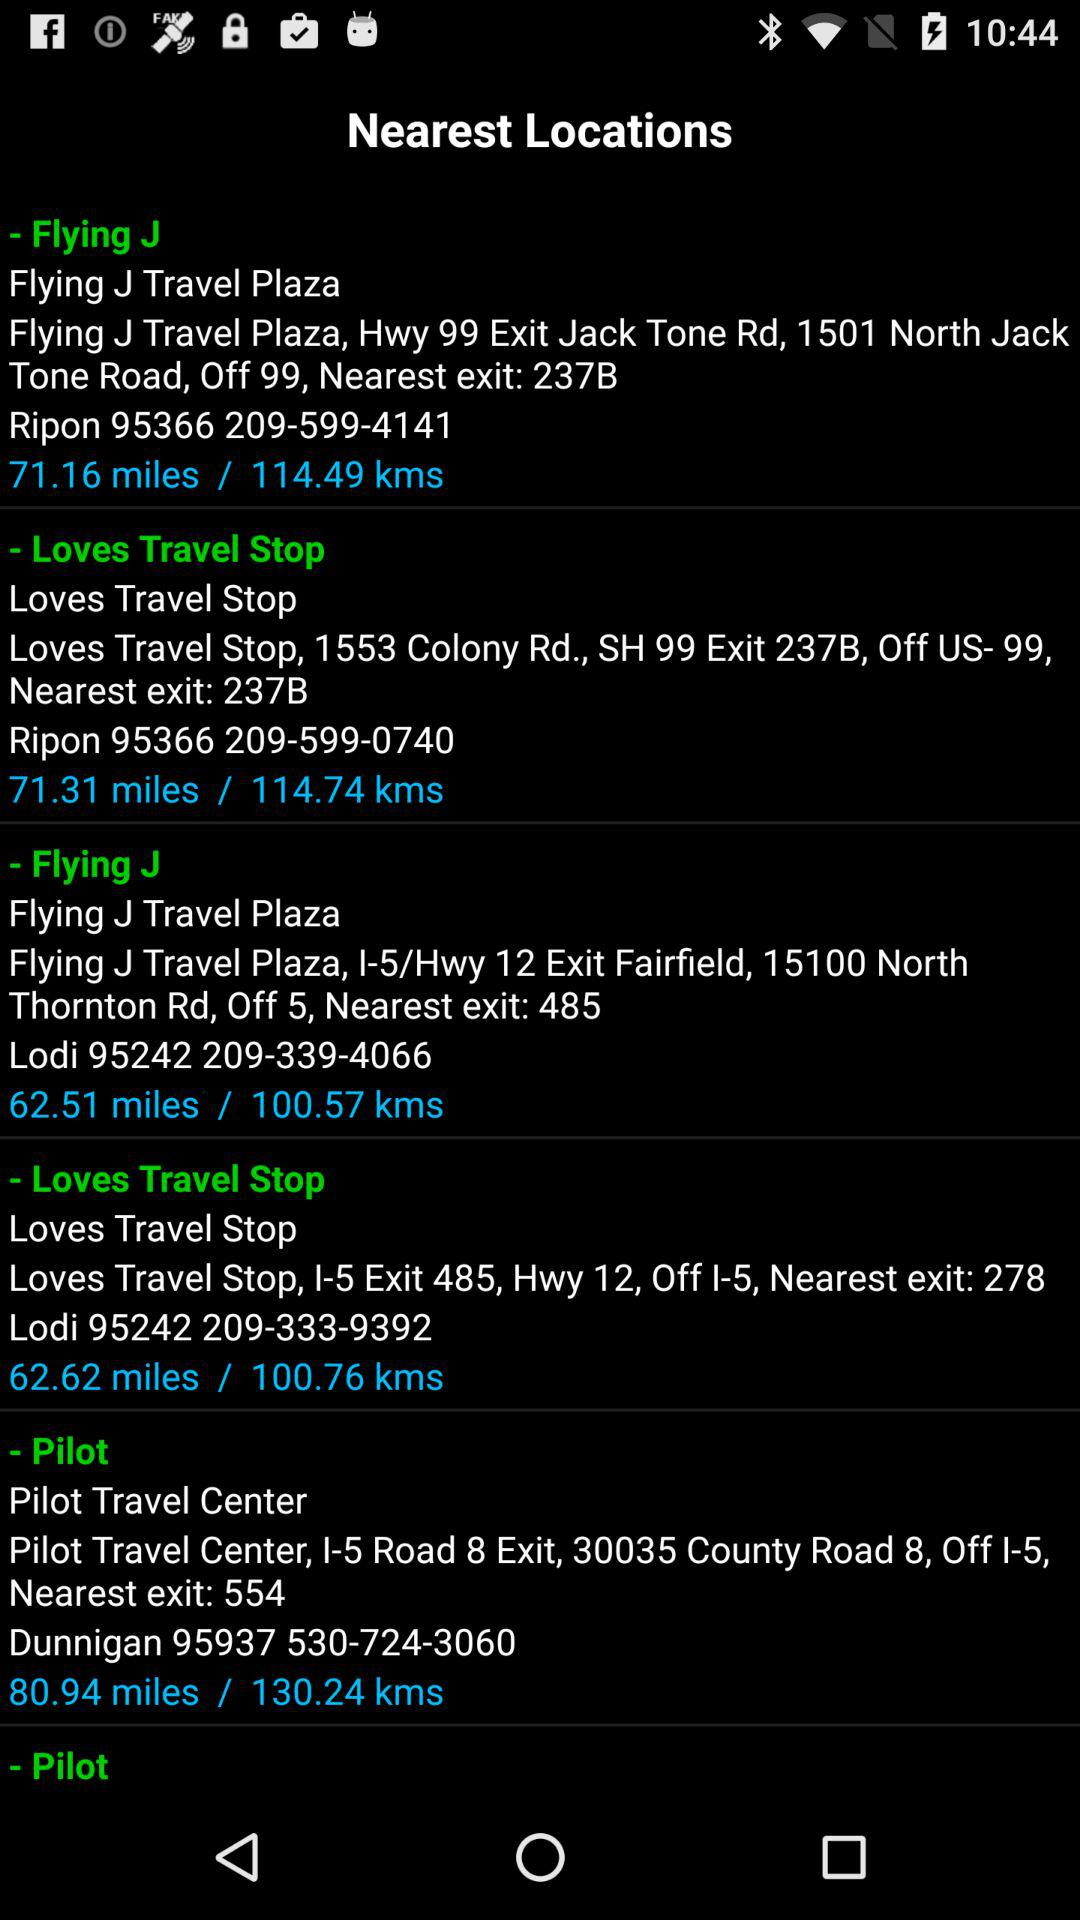What is the distance of "Pilot" from my location? The distance is 80.94 miles. 